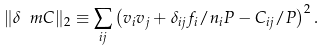Convert formula to latex. <formula><loc_0><loc_0><loc_500><loc_500>\| \delta \ m C \| _ { 2 } \equiv \sum _ { i j } \left ( v _ { i } v _ { j } + \delta _ { i j } f _ { i } / n _ { i } P - C _ { i j } / P \right ) ^ { 2 } .</formula> 